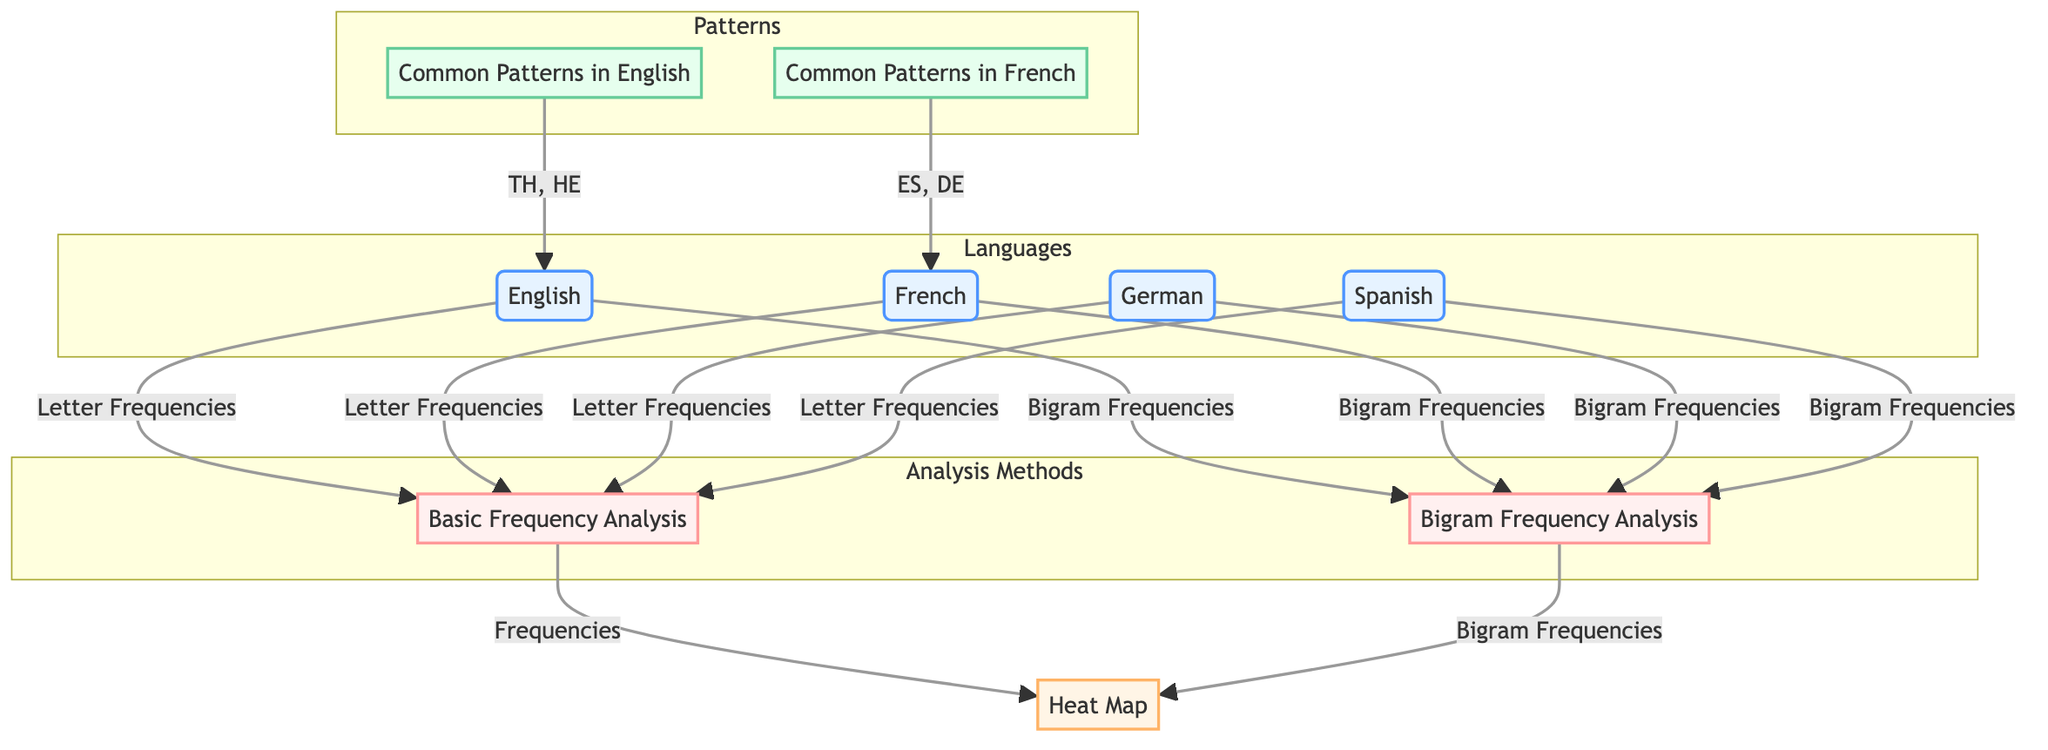What languages are represented in the diagram? The diagram includes four languages: English, French, German, and Spanish, which can be identified in the 'Languages' subgraph on the left side.
Answer: English, French, German, Spanish How many analysis methods are shown in the diagram? There are two analysis methods indicated in the 'Analysis Methods' subgraph: Basic Frequency Analysis and Bigram Frequency Analysis, as seen in the diagram.
Answer: 2 Which language has common patterns labeled as "TH, HE"? The pattern "TH, HE" is associated with English, as indicated by the 'Common Patterns in English' node which connects to the English language node.
Answer: English What kind of frequencies do all languages use in basic frequency analysis? All languages utilize letter frequencies for basic frequency analysis, which is represented by the connections from each language to the Basic Frequency Analysis node.
Answer: Letter Frequencies Which language shows common patterns "ES, DE"? The pattern "ES, DE" is linked to French, as shown in the diagram next to the 'Common Patterns in French' node.
Answer: French Which analysis method uses bigram frequencies? Both analysis methods labeled 'Basic Frequency Analysis' and 'Bigram Frequency Analysis' utilize bigram frequencies, but only the Bigram Frequency Analysis node is directly labeled as using them.
Answer: Bigram Frequency Analysis How many nodes are present in the 'Patterns' subgraph? The 'Patterns' subgraph contains two nodes: 'Common Patterns in English' and 'Common Patterns in French.' By counting them, we find a total of two nodes in that section.
Answer: 2 Which language does not directly link to a common pattern in the diagram? The German language does not have a direct link to any common pattern as it exists only in the language node, without any associated pattern node.
Answer: German 